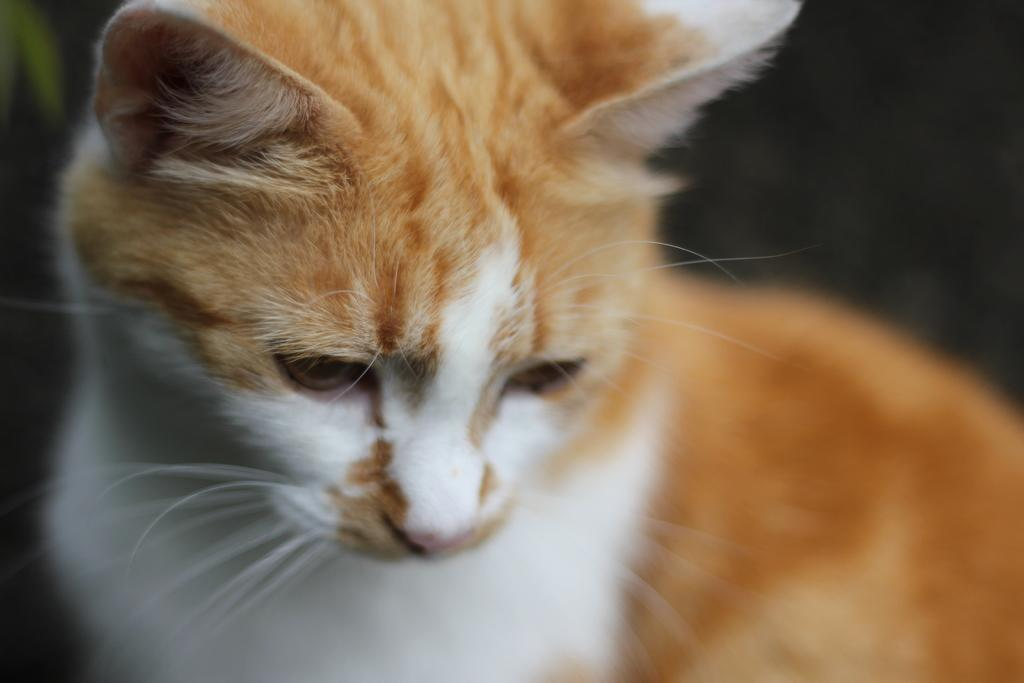What type of animal is present in the image? There is a cat in the image. What type of hospital is depicted in the image? There is no hospital present in the image; it features a cat. What territory is being claimed by the cat in the image? The image does not depict the cat claiming any territory. 